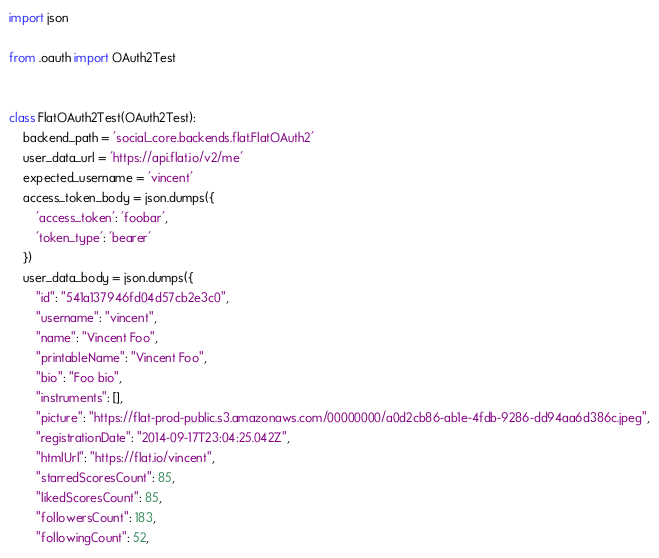Convert code to text. <code><loc_0><loc_0><loc_500><loc_500><_Python_>import json

from .oauth import OAuth2Test


class FlatOAuth2Test(OAuth2Test):
    backend_path = 'social_core.backends.flat.FlatOAuth2'
    user_data_url = 'https://api.flat.io/v2/me'
    expected_username = 'vincent'
    access_token_body = json.dumps({
        'access_token': 'foobar',
        'token_type': 'bearer'
    })
    user_data_body = json.dumps({
        "id": "541a137946fd04d57cb2e3c0",
        "username": "vincent",
        "name": "Vincent Foo",
        "printableName": "Vincent Foo",
        "bio": "Foo bio",
        "instruments": [],
        "picture": "https://flat-prod-public.s3.amazonaws.com/00000000/a0d2cb86-ab1e-4fdb-9286-dd94aa6d386c.jpeg",
        "registrationDate": "2014-09-17T23:04:25.042Z",
        "htmlUrl": "https://flat.io/vincent",
        "starredScoresCount": 85,
        "likedScoresCount": 85,
        "followersCount": 183,
        "followingCount": 52,</code> 